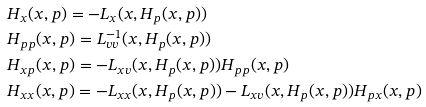<formula> <loc_0><loc_0><loc_500><loc_500>& H _ { x } ( x , p ) = - L _ { x } ( x , H _ { p } ( x , p ) ) \\ & H _ { p p } ( x , p ) = L ^ { - 1 } _ { v v } ( x , H _ { p } ( x , p ) ) \\ & H _ { x p } ( x , p ) = - L _ { x v } ( x , H _ { p } ( x , p ) ) H _ { p p } ( x , p ) \\ & H _ { x x } ( x , p ) = - L _ { x x } ( x , H _ { p } ( x , p ) ) - L _ { x v } ( x , H _ { p } ( x , p ) ) H _ { p x } ( x , p )</formula> 